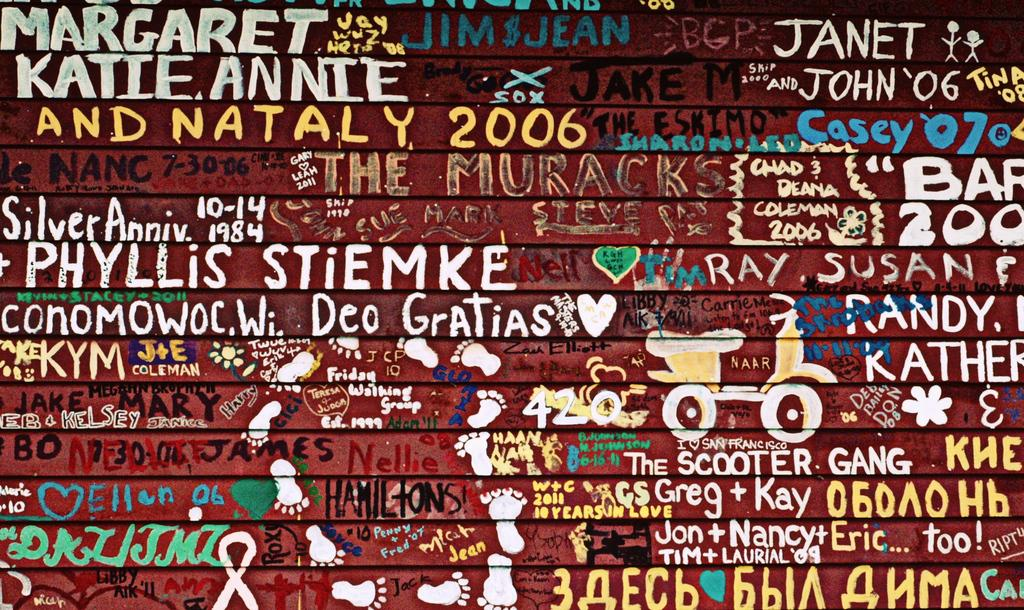<image>
Summarize the visual content of the image. wall that has many things painted on it such as katie annie and nataly 2006, janet and john '06, and the scooter gang 